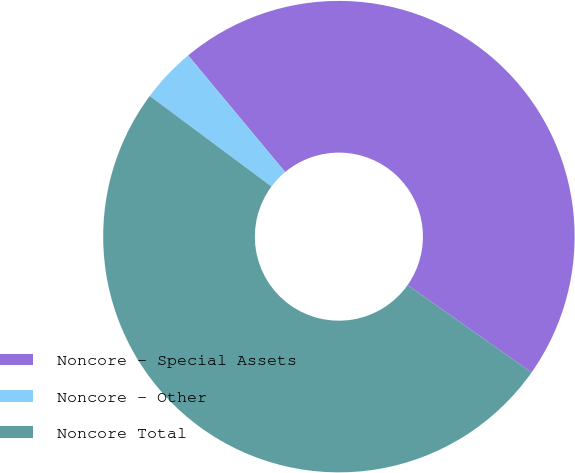Convert chart. <chart><loc_0><loc_0><loc_500><loc_500><pie_chart><fcel>Noncore - Special Assets<fcel>Noncore - Other<fcel>Noncore Total<nl><fcel>45.82%<fcel>3.78%<fcel>50.4%<nl></chart> 